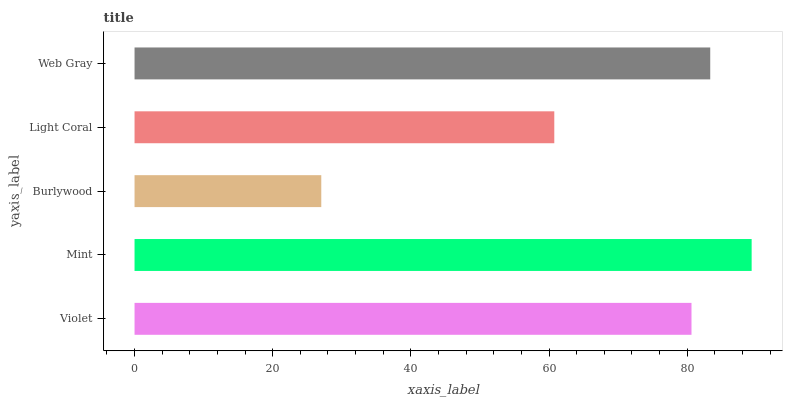Is Burlywood the minimum?
Answer yes or no. Yes. Is Mint the maximum?
Answer yes or no. Yes. Is Mint the minimum?
Answer yes or no. No. Is Burlywood the maximum?
Answer yes or no. No. Is Mint greater than Burlywood?
Answer yes or no. Yes. Is Burlywood less than Mint?
Answer yes or no. Yes. Is Burlywood greater than Mint?
Answer yes or no. No. Is Mint less than Burlywood?
Answer yes or no. No. Is Violet the high median?
Answer yes or no. Yes. Is Violet the low median?
Answer yes or no. Yes. Is Burlywood the high median?
Answer yes or no. No. Is Web Gray the low median?
Answer yes or no. No. 